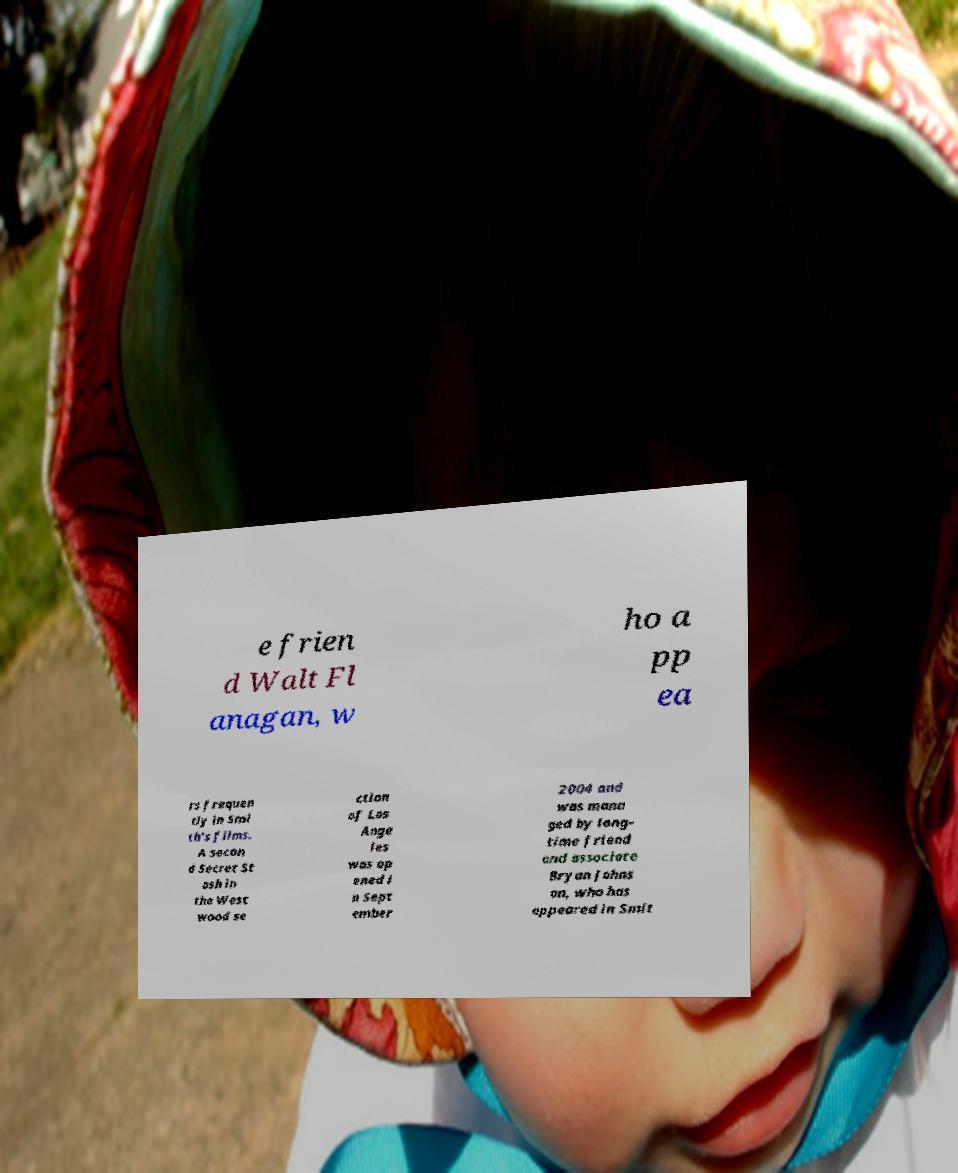For documentation purposes, I need the text within this image transcribed. Could you provide that? e frien d Walt Fl anagan, w ho a pp ea rs frequen tly in Smi th's films. A secon d Secret St ash in the West wood se ction of Los Ange les was op ened i n Sept ember 2004 and was mana ged by long- time friend and associate Bryan Johns on, who has appeared in Smit 